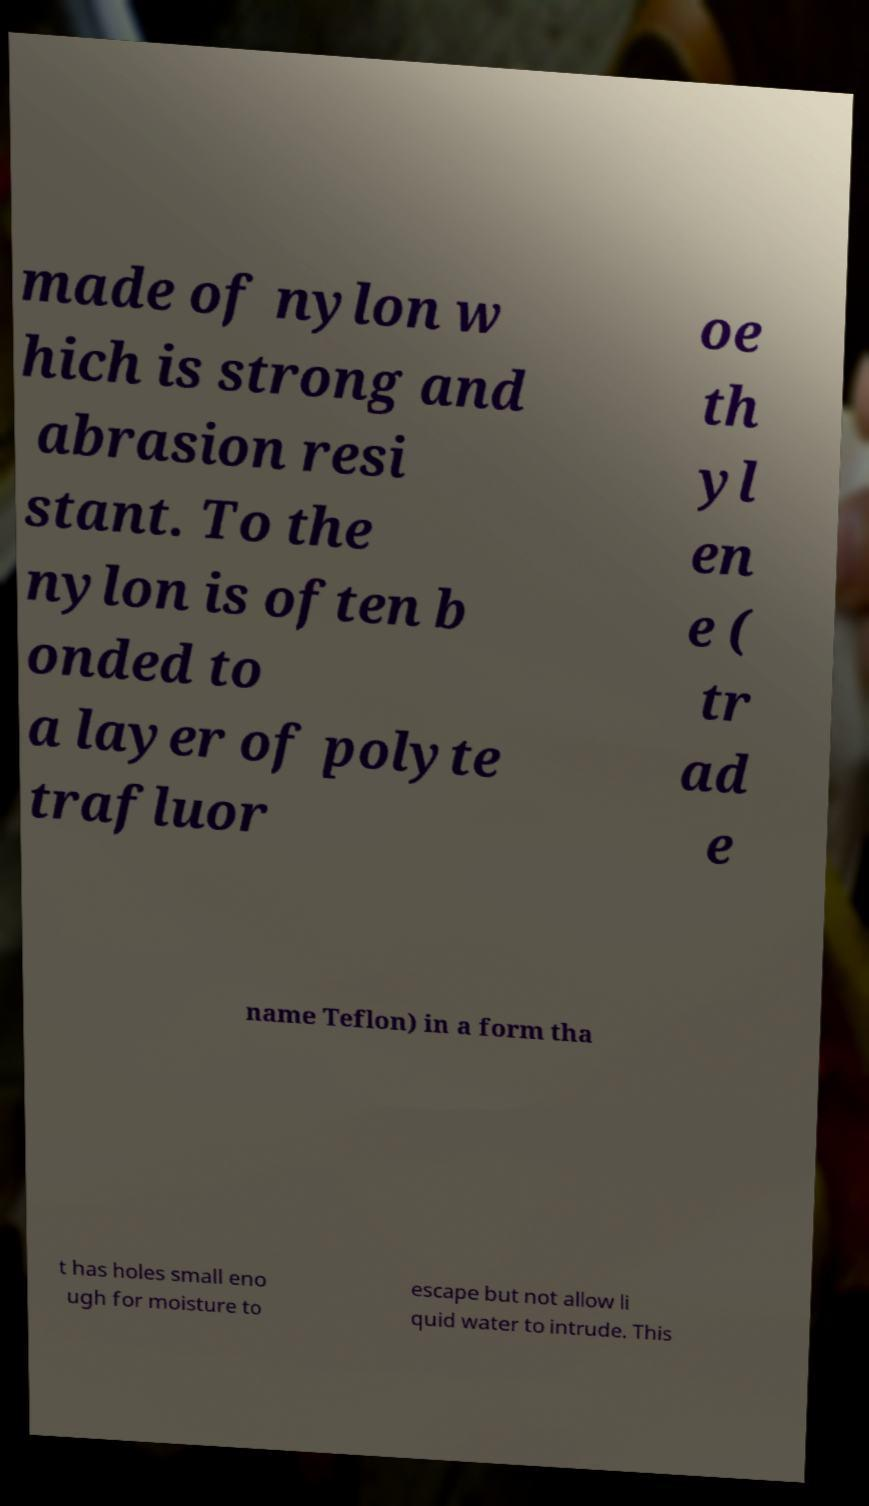For documentation purposes, I need the text within this image transcribed. Could you provide that? made of nylon w hich is strong and abrasion resi stant. To the nylon is often b onded to a layer of polyte trafluor oe th yl en e ( tr ad e name Teflon) in a form tha t has holes small eno ugh for moisture to escape but not allow li quid water to intrude. This 